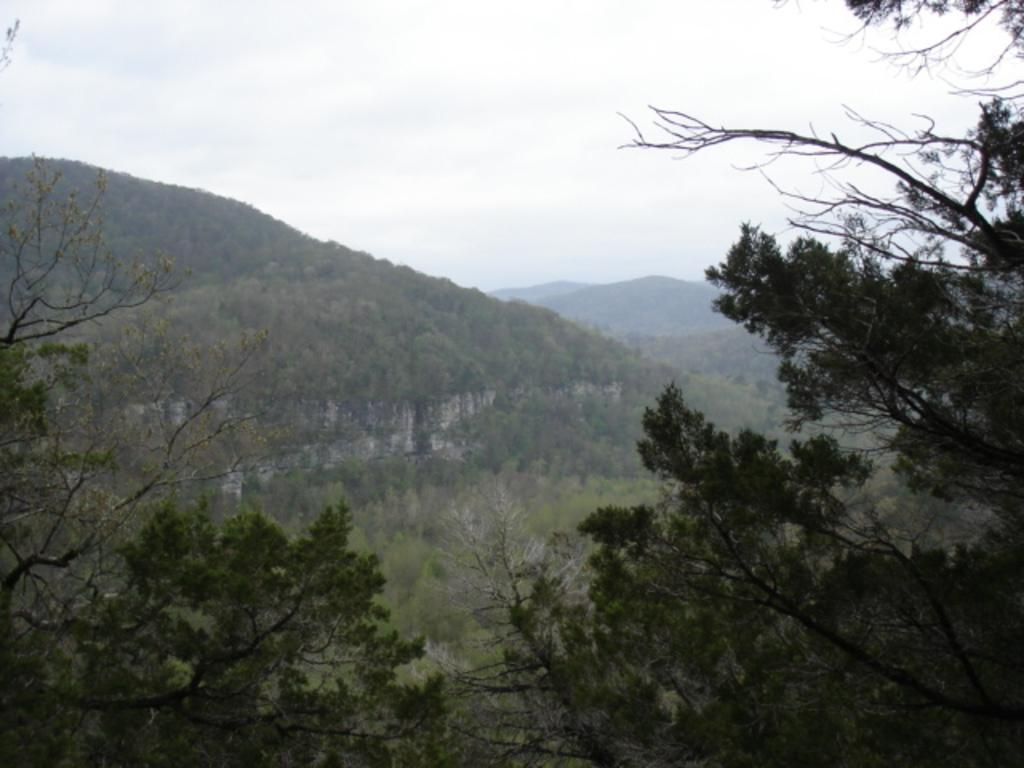What type of vegetation can be seen in the image? There are trees in the image. What can be seen in the distance in the image? There are hills visible in the background of the image. What part of the natural environment is visible in the image? The sky is visible in the image. What type of alarm is ringing in the image? There is no alarm present in the image. What type of coal is visible in the image? There is no coal present in the image. 